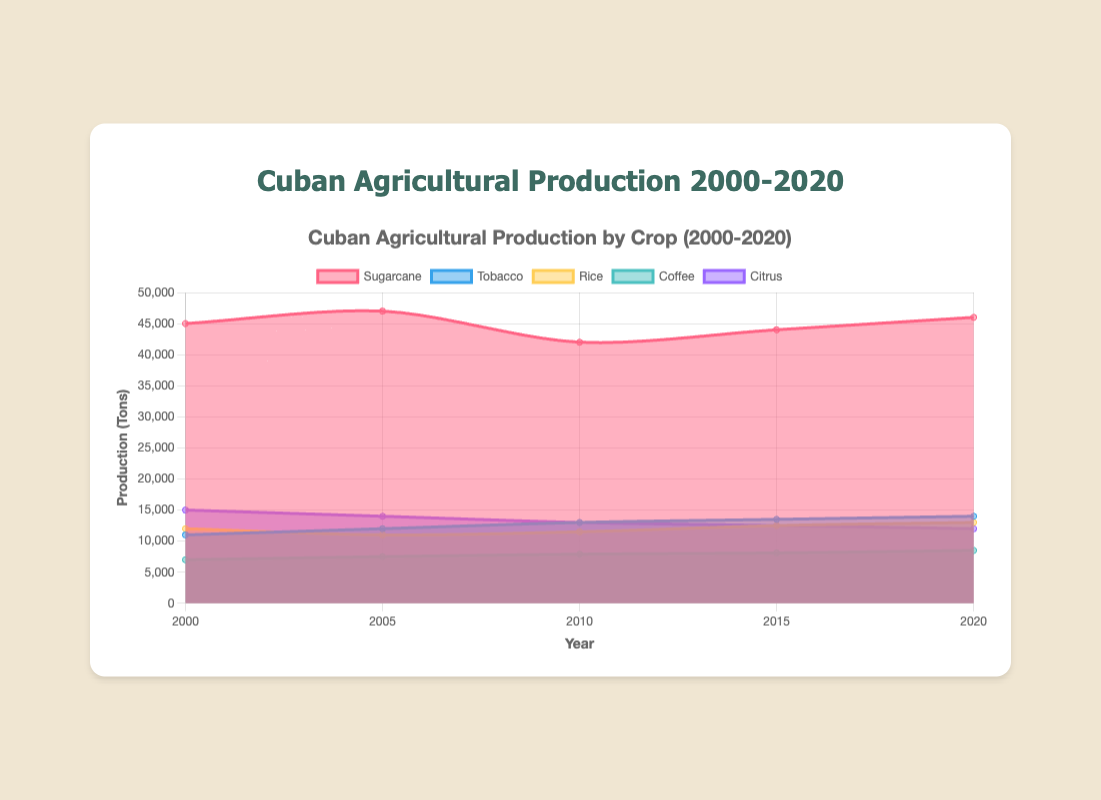What's the title of the chart? The title is usually displayed at the top of the chart. In this case, it reads "Cuban Agricultural Production by Crop (2000-2020)"
Answer: Cuban Agricultural Production by Crop (2000-2020) How many different crops are shown in the chart? The legend shows the different colored sections indicating the number of crops represented in the chart. The chart shows five different crops: Sugarcane, Tobacco, Rice, Coffee, and Citrus
Answer: 5 Which crop had the highest production in 2000? Look at the data points for each crop in the year 2000 on the x-axis and identify the crop with the highest production. Sugarcane has the highest production at 45,000 tons
Answer: Sugarcane Did the production of tobacco increase or decrease from 2000 to 2020? Compare the data points for tobacco in the years 2000 and 2020. Tobacco production increases from 11,000 tons in 2000 to 14,000 tons in 2020
Answer: Increase Which crop showed the most consistent production from 2000 to 2020? Consistent production implies little variability in the data points over the years. Tobacco shows the most consistent production, gradually increasing from 11,000 tons to 14,000 tons
Answer: Tobacco What was the total agricultural production for all crops combined in 2010? Sum the production values for all five crops in 2010: 42,000 (Sugarcane) + 13,000 (Tobacco) + 11,500 (Rice) + 7,900 (Coffee) + 13,000 (Citrus) = 87,400
Answer: 87,400 By how much did Rice production vary between its highest and lowest values from 2000 to 2020? Identify the highest and lowest production values for Rice in the given years. The highest is 13,000 tons in 2020, and the lowest is 11,000 tons in 2005 and the difference is 13,000 - 11,000 = 2,000 tons
Answer: 2,000 Which crop had a decrease in production from 2010 to 2020? Compare the data points for each crop in 2010 and 2020. Citrus production decreases from 13,000 tons in 2010 to 12,000 tons in 2020
Answer: Citrus What is the average production of Coffee from 2000 to 2020? Sum all data points for Coffee and divide by the number of data points: (7,000 + 7,500 + 7,900 + 8,100 + 8,500) / 5 = 39,000 / 5 = 7,800
Answer: 7,800 How does the production trend of Sugarcane compare to Citrus from 2000 to 2020? Compare the trends by looking at how each crop's production changes over the years. Sugarcane shows some fluctuation but generally increases, whereas Citrus shows a steady decline
Answer: Sugarcane fluctuates, Citrus declines 